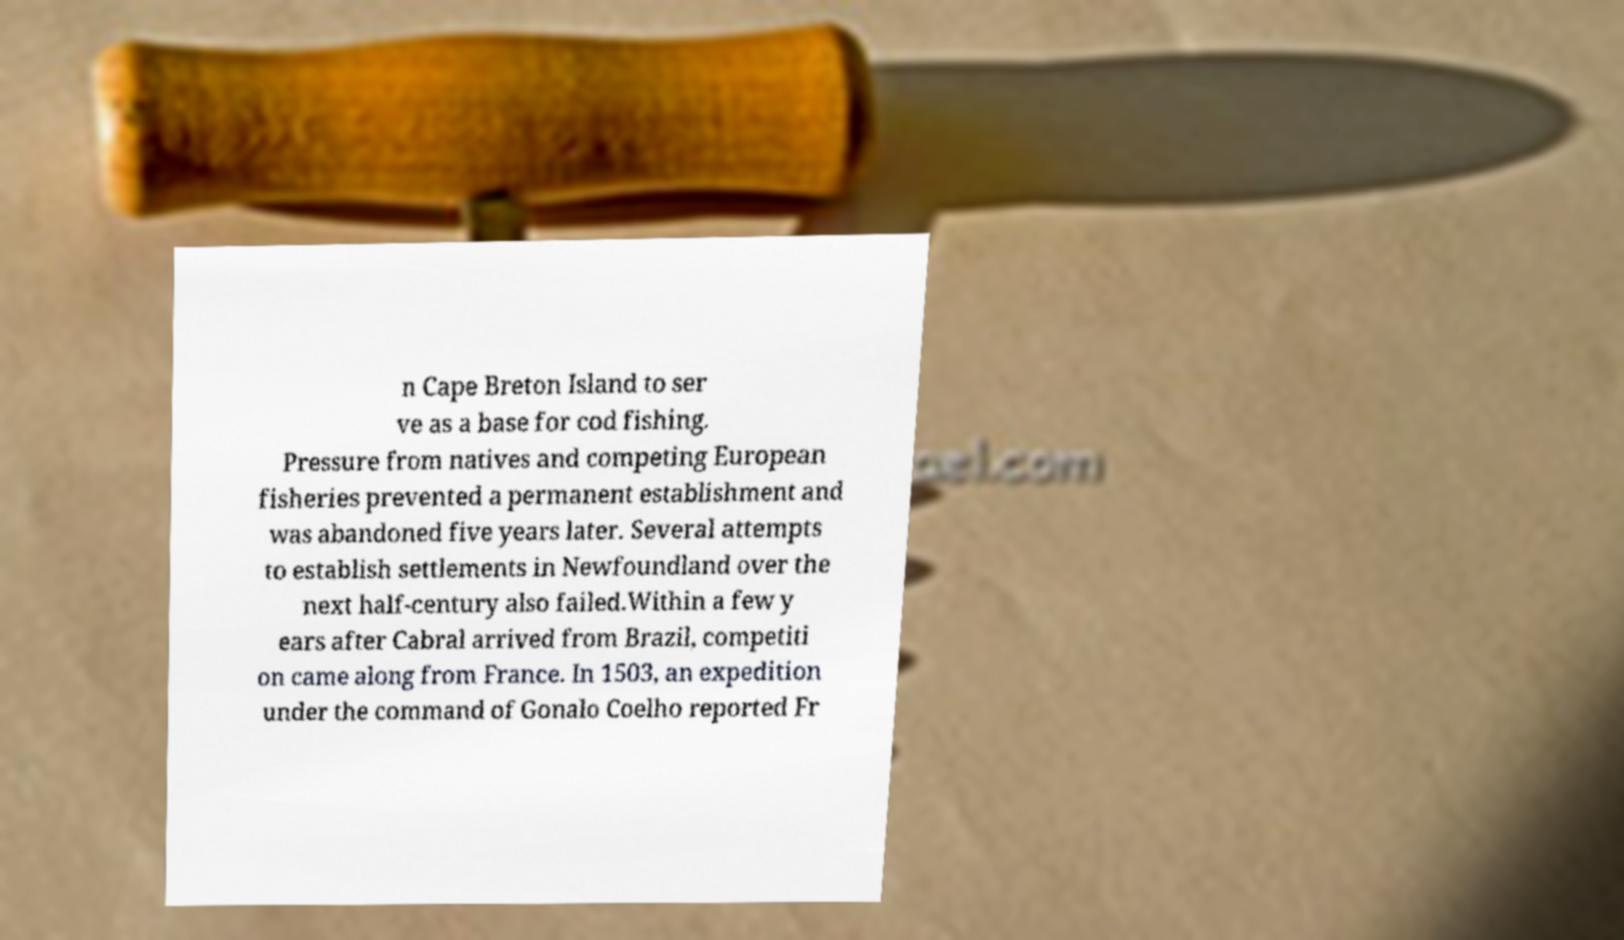Could you extract and type out the text from this image? n Cape Breton Island to ser ve as a base for cod fishing. Pressure from natives and competing European fisheries prevented a permanent establishment and was abandoned five years later. Several attempts to establish settlements in Newfoundland over the next half-century also failed.Within a few y ears after Cabral arrived from Brazil, competiti on came along from France. In 1503, an expedition under the command of Gonalo Coelho reported Fr 